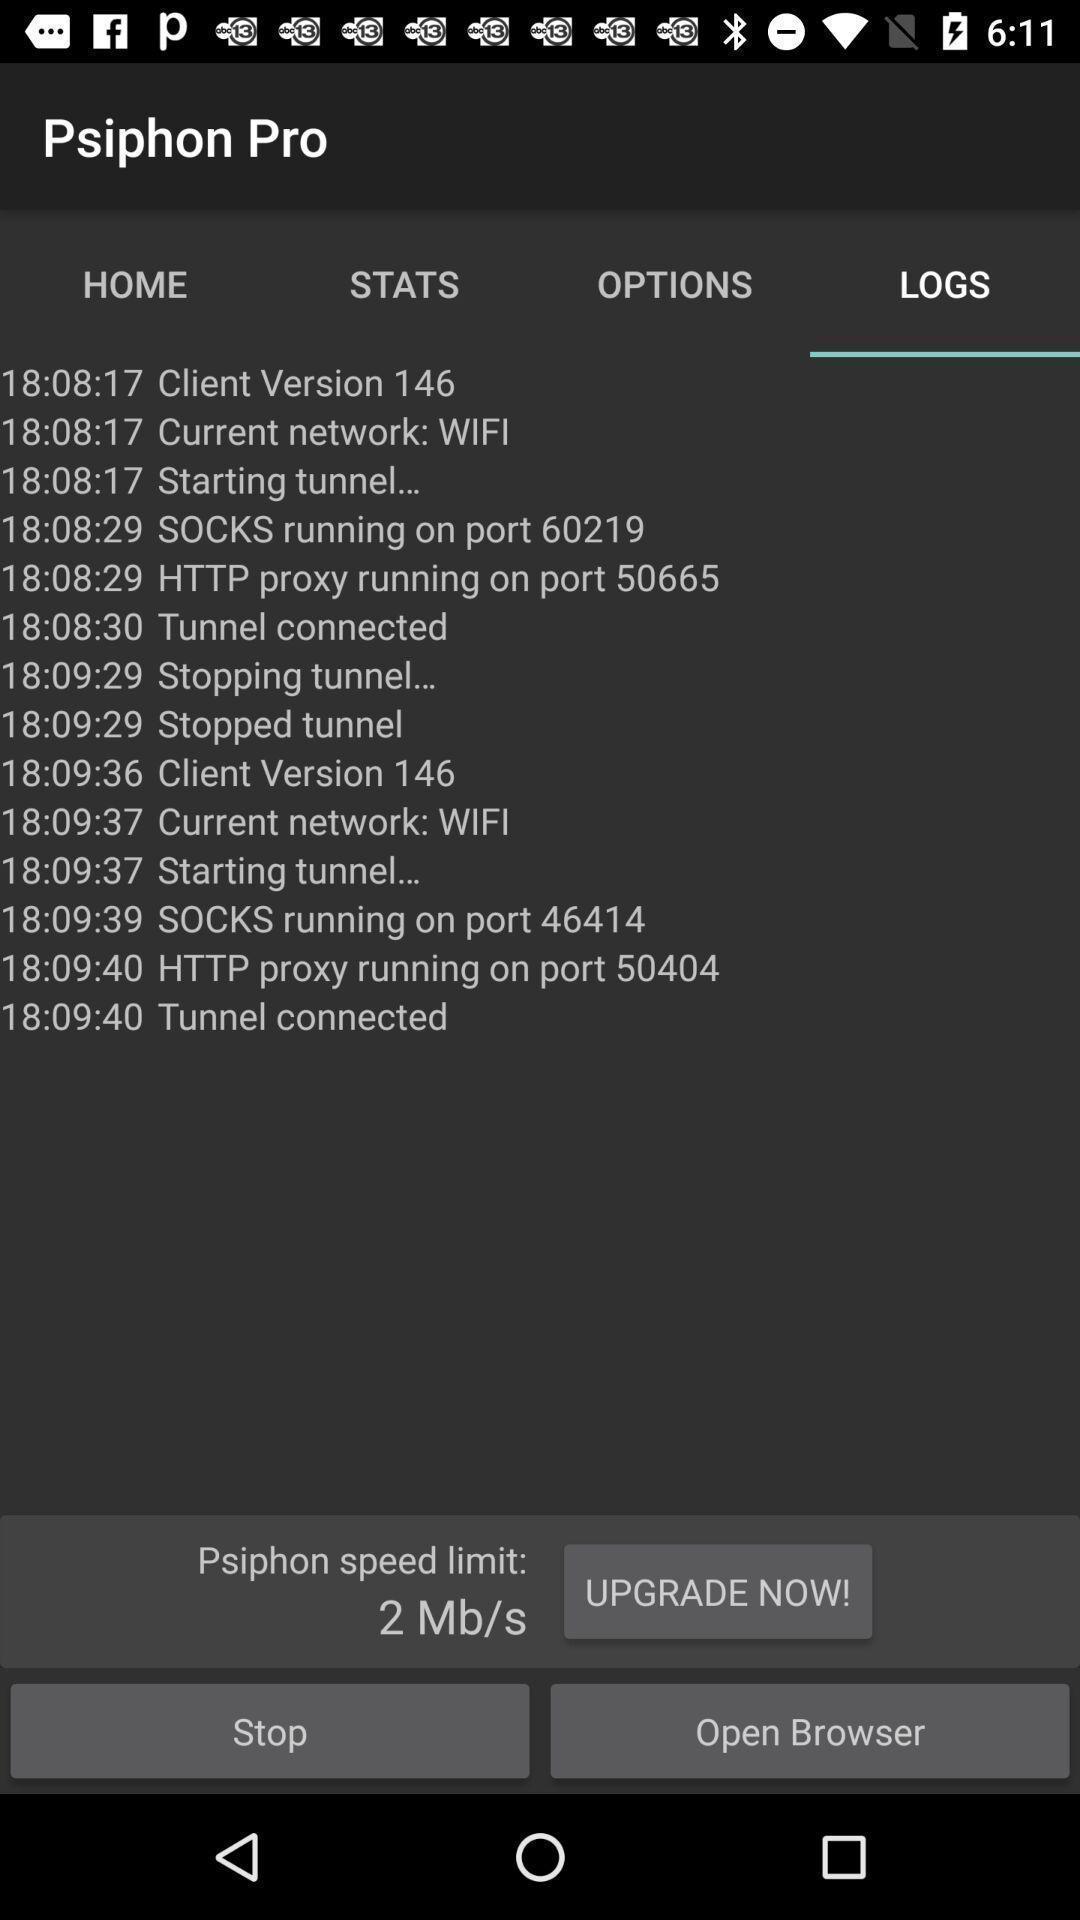What details can you identify in this image? Page displaying to upgrade a app now. 